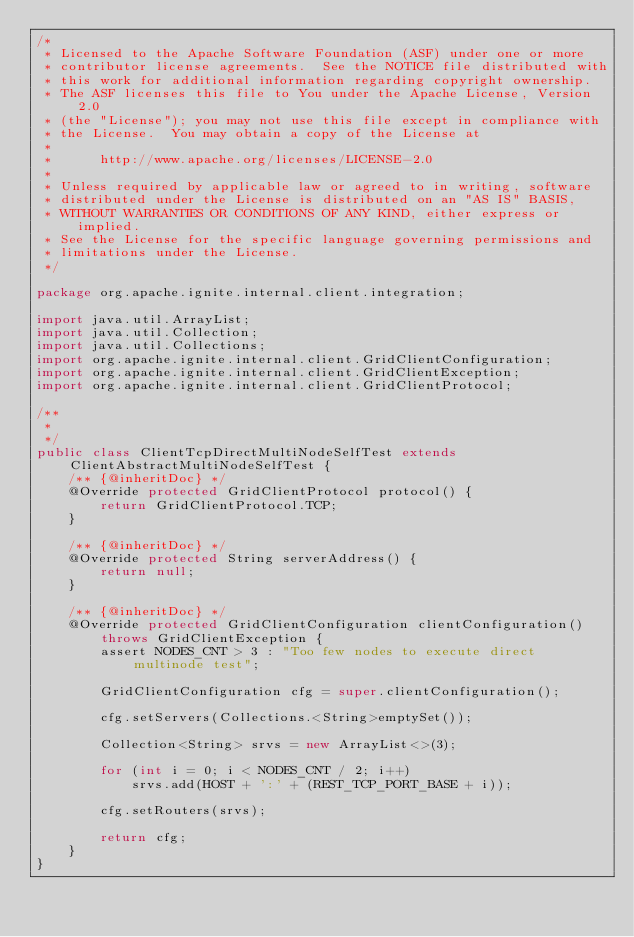Convert code to text. <code><loc_0><loc_0><loc_500><loc_500><_Java_>/*
 * Licensed to the Apache Software Foundation (ASF) under one or more
 * contributor license agreements.  See the NOTICE file distributed with
 * this work for additional information regarding copyright ownership.
 * The ASF licenses this file to You under the Apache License, Version 2.0
 * (the "License"); you may not use this file except in compliance with
 * the License.  You may obtain a copy of the License at
 *
 *      http://www.apache.org/licenses/LICENSE-2.0
 *
 * Unless required by applicable law or agreed to in writing, software
 * distributed under the License is distributed on an "AS IS" BASIS,
 * WITHOUT WARRANTIES OR CONDITIONS OF ANY KIND, either express or implied.
 * See the License for the specific language governing permissions and
 * limitations under the License.
 */

package org.apache.ignite.internal.client.integration;

import java.util.ArrayList;
import java.util.Collection;
import java.util.Collections;
import org.apache.ignite.internal.client.GridClientConfiguration;
import org.apache.ignite.internal.client.GridClientException;
import org.apache.ignite.internal.client.GridClientProtocol;

/**
 *
 */
public class ClientTcpDirectMultiNodeSelfTest extends ClientAbstractMultiNodeSelfTest {
    /** {@inheritDoc} */
    @Override protected GridClientProtocol protocol() {
        return GridClientProtocol.TCP;
    }

    /** {@inheritDoc} */
    @Override protected String serverAddress() {
        return null;
    }

    /** {@inheritDoc} */
    @Override protected GridClientConfiguration clientConfiguration() throws GridClientException {
        assert NODES_CNT > 3 : "Too few nodes to execute direct multinode test";

        GridClientConfiguration cfg = super.clientConfiguration();

        cfg.setServers(Collections.<String>emptySet());

        Collection<String> srvs = new ArrayList<>(3);

        for (int i = 0; i < NODES_CNT / 2; i++)
            srvs.add(HOST + ':' + (REST_TCP_PORT_BASE + i));

        cfg.setRouters(srvs);

        return cfg;
    }
}</code> 